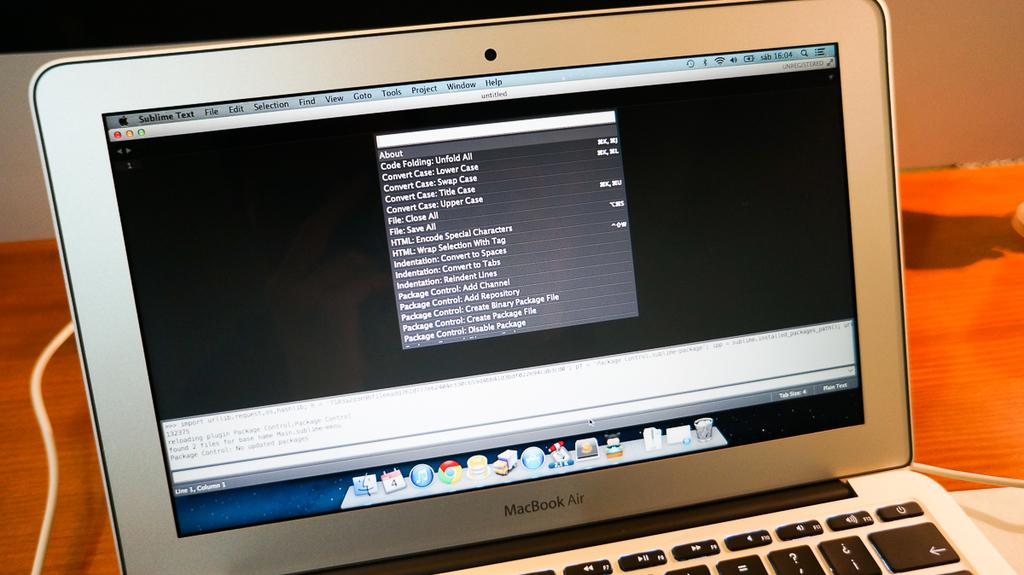<image>
Summarize the visual content of the image. a silver macbook air open to a mostly black screen 